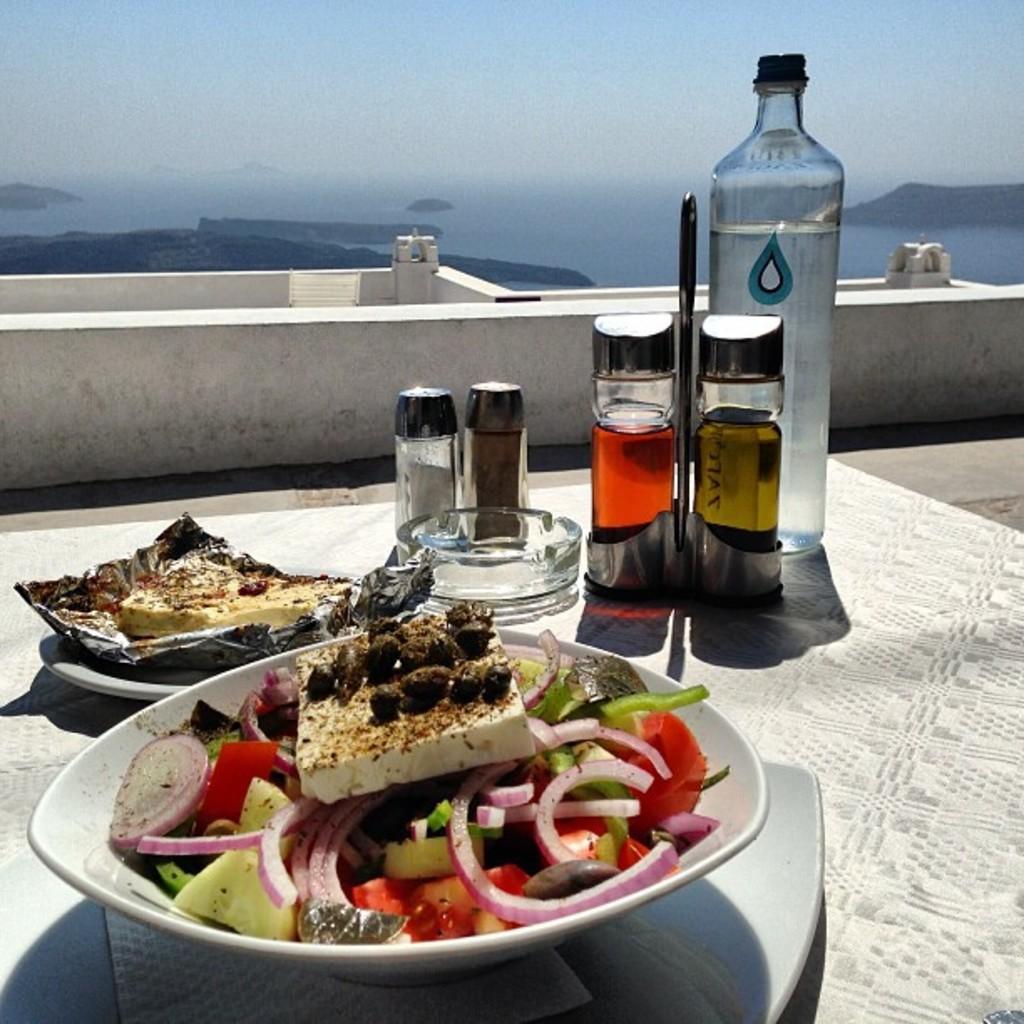How would you summarize this image in a sentence or two? In this image we can see plate with food, ashtray and bottles on the table. In the background we can see water, mountains and sky. 